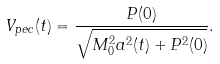Convert formula to latex. <formula><loc_0><loc_0><loc_500><loc_500>V _ { p e c } ( t ) = \frac { P ( 0 ) } { \sqrt { M _ { 0 } ^ { 2 } a ^ { 2 } ( t ) + P ^ { 2 } ( 0 ) } } .</formula> 